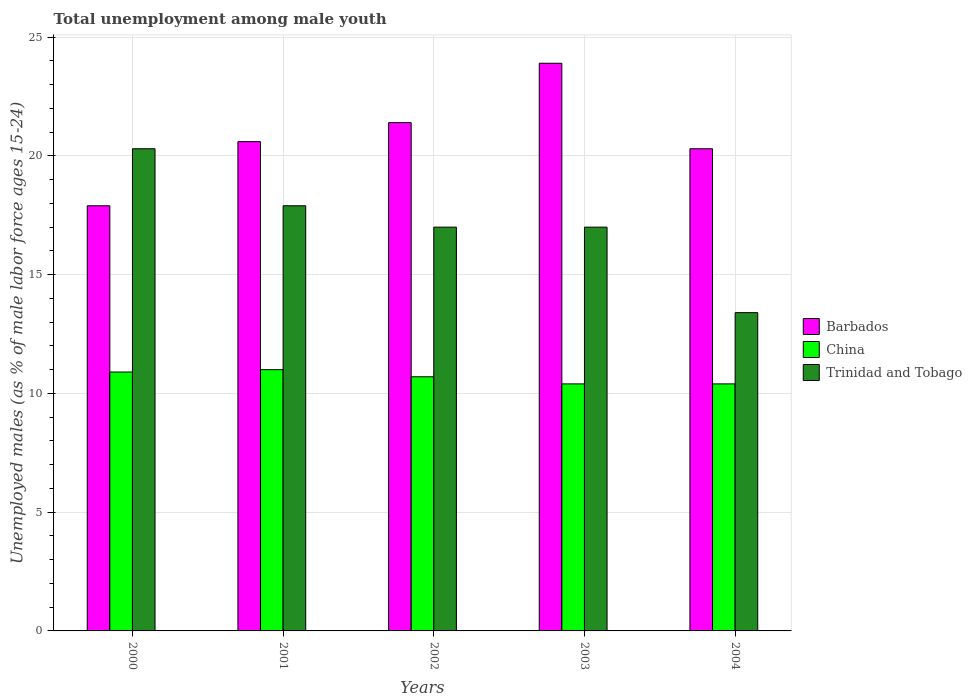How many groups of bars are there?
Give a very brief answer. 5. Are the number of bars on each tick of the X-axis equal?
Offer a terse response. Yes. How many bars are there on the 2nd tick from the right?
Provide a succinct answer. 3. What is the label of the 3rd group of bars from the left?
Offer a very short reply. 2002. What is the percentage of unemployed males in in China in 2002?
Keep it short and to the point. 10.7. Across all years, what is the maximum percentage of unemployed males in in Barbados?
Provide a short and direct response. 23.9. Across all years, what is the minimum percentage of unemployed males in in China?
Your response must be concise. 10.4. What is the total percentage of unemployed males in in China in the graph?
Ensure brevity in your answer.  53.4. What is the difference between the percentage of unemployed males in in Trinidad and Tobago in 2001 and that in 2004?
Offer a very short reply. 4.5. What is the average percentage of unemployed males in in Barbados per year?
Provide a succinct answer. 20.82. In the year 2002, what is the difference between the percentage of unemployed males in in Barbados and percentage of unemployed males in in Trinidad and Tobago?
Ensure brevity in your answer.  4.4. In how many years, is the percentage of unemployed males in in Trinidad and Tobago greater than 15 %?
Offer a terse response. 4. What is the ratio of the percentage of unemployed males in in Trinidad and Tobago in 2001 to that in 2002?
Your answer should be compact. 1.05. Is the percentage of unemployed males in in Barbados in 2000 less than that in 2001?
Offer a terse response. Yes. Is the difference between the percentage of unemployed males in in Barbados in 2001 and 2002 greater than the difference between the percentage of unemployed males in in Trinidad and Tobago in 2001 and 2002?
Offer a terse response. No. What is the difference between the highest and the second highest percentage of unemployed males in in China?
Provide a short and direct response. 0.1. What is the difference between the highest and the lowest percentage of unemployed males in in Barbados?
Make the answer very short. 6. In how many years, is the percentage of unemployed males in in Barbados greater than the average percentage of unemployed males in in Barbados taken over all years?
Provide a succinct answer. 2. Is the sum of the percentage of unemployed males in in Barbados in 2003 and 2004 greater than the maximum percentage of unemployed males in in Trinidad and Tobago across all years?
Provide a short and direct response. Yes. What does the 1st bar from the left in 2000 represents?
Ensure brevity in your answer.  Barbados. What does the 1st bar from the right in 2004 represents?
Keep it short and to the point. Trinidad and Tobago. Is it the case that in every year, the sum of the percentage of unemployed males in in Trinidad and Tobago and percentage of unemployed males in in Barbados is greater than the percentage of unemployed males in in China?
Keep it short and to the point. Yes. Are all the bars in the graph horizontal?
Provide a succinct answer. No. How many years are there in the graph?
Offer a very short reply. 5. Are the values on the major ticks of Y-axis written in scientific E-notation?
Offer a very short reply. No. Does the graph contain any zero values?
Make the answer very short. No. Does the graph contain grids?
Your response must be concise. Yes. Where does the legend appear in the graph?
Offer a very short reply. Center right. How are the legend labels stacked?
Provide a succinct answer. Vertical. What is the title of the graph?
Your answer should be compact. Total unemployment among male youth. What is the label or title of the Y-axis?
Make the answer very short. Unemployed males (as % of male labor force ages 15-24). What is the Unemployed males (as % of male labor force ages 15-24) of Barbados in 2000?
Keep it short and to the point. 17.9. What is the Unemployed males (as % of male labor force ages 15-24) of China in 2000?
Offer a very short reply. 10.9. What is the Unemployed males (as % of male labor force ages 15-24) in Trinidad and Tobago in 2000?
Your response must be concise. 20.3. What is the Unemployed males (as % of male labor force ages 15-24) of Barbados in 2001?
Provide a short and direct response. 20.6. What is the Unemployed males (as % of male labor force ages 15-24) in China in 2001?
Keep it short and to the point. 11. What is the Unemployed males (as % of male labor force ages 15-24) in Trinidad and Tobago in 2001?
Your answer should be very brief. 17.9. What is the Unemployed males (as % of male labor force ages 15-24) in Barbados in 2002?
Provide a succinct answer. 21.4. What is the Unemployed males (as % of male labor force ages 15-24) of China in 2002?
Keep it short and to the point. 10.7. What is the Unemployed males (as % of male labor force ages 15-24) of Trinidad and Tobago in 2002?
Offer a very short reply. 17. What is the Unemployed males (as % of male labor force ages 15-24) in Barbados in 2003?
Offer a terse response. 23.9. What is the Unemployed males (as % of male labor force ages 15-24) of China in 2003?
Provide a short and direct response. 10.4. What is the Unemployed males (as % of male labor force ages 15-24) in Barbados in 2004?
Your answer should be compact. 20.3. What is the Unemployed males (as % of male labor force ages 15-24) of China in 2004?
Ensure brevity in your answer.  10.4. What is the Unemployed males (as % of male labor force ages 15-24) of Trinidad and Tobago in 2004?
Ensure brevity in your answer.  13.4. Across all years, what is the maximum Unemployed males (as % of male labor force ages 15-24) of Barbados?
Offer a very short reply. 23.9. Across all years, what is the maximum Unemployed males (as % of male labor force ages 15-24) in China?
Make the answer very short. 11. Across all years, what is the maximum Unemployed males (as % of male labor force ages 15-24) of Trinidad and Tobago?
Your response must be concise. 20.3. Across all years, what is the minimum Unemployed males (as % of male labor force ages 15-24) in Barbados?
Offer a very short reply. 17.9. Across all years, what is the minimum Unemployed males (as % of male labor force ages 15-24) of China?
Your answer should be compact. 10.4. Across all years, what is the minimum Unemployed males (as % of male labor force ages 15-24) of Trinidad and Tobago?
Offer a very short reply. 13.4. What is the total Unemployed males (as % of male labor force ages 15-24) of Barbados in the graph?
Your answer should be compact. 104.1. What is the total Unemployed males (as % of male labor force ages 15-24) of China in the graph?
Offer a very short reply. 53.4. What is the total Unemployed males (as % of male labor force ages 15-24) of Trinidad and Tobago in the graph?
Offer a very short reply. 85.6. What is the difference between the Unemployed males (as % of male labor force ages 15-24) in China in 2000 and that in 2001?
Offer a terse response. -0.1. What is the difference between the Unemployed males (as % of male labor force ages 15-24) in Barbados in 2000 and that in 2002?
Your response must be concise. -3.5. What is the difference between the Unemployed males (as % of male labor force ages 15-24) of Trinidad and Tobago in 2000 and that in 2002?
Your response must be concise. 3.3. What is the difference between the Unemployed males (as % of male labor force ages 15-24) in Barbados in 2000 and that in 2003?
Give a very brief answer. -6. What is the difference between the Unemployed males (as % of male labor force ages 15-24) of China in 2000 and that in 2003?
Provide a succinct answer. 0.5. What is the difference between the Unemployed males (as % of male labor force ages 15-24) in Barbados in 2000 and that in 2004?
Your answer should be compact. -2.4. What is the difference between the Unemployed males (as % of male labor force ages 15-24) in Barbados in 2001 and that in 2002?
Offer a very short reply. -0.8. What is the difference between the Unemployed males (as % of male labor force ages 15-24) of Barbados in 2001 and that in 2003?
Your answer should be very brief. -3.3. What is the difference between the Unemployed males (as % of male labor force ages 15-24) of Trinidad and Tobago in 2001 and that in 2003?
Offer a very short reply. 0.9. What is the difference between the Unemployed males (as % of male labor force ages 15-24) in Barbados in 2002 and that in 2003?
Your response must be concise. -2.5. What is the difference between the Unemployed males (as % of male labor force ages 15-24) in China in 2002 and that in 2003?
Ensure brevity in your answer.  0.3. What is the difference between the Unemployed males (as % of male labor force ages 15-24) in Trinidad and Tobago in 2002 and that in 2003?
Ensure brevity in your answer.  0. What is the difference between the Unemployed males (as % of male labor force ages 15-24) in China in 2003 and that in 2004?
Offer a terse response. 0. What is the difference between the Unemployed males (as % of male labor force ages 15-24) of Trinidad and Tobago in 2003 and that in 2004?
Provide a short and direct response. 3.6. What is the difference between the Unemployed males (as % of male labor force ages 15-24) in Barbados in 2000 and the Unemployed males (as % of male labor force ages 15-24) in Trinidad and Tobago in 2001?
Your answer should be compact. 0. What is the difference between the Unemployed males (as % of male labor force ages 15-24) in China in 2000 and the Unemployed males (as % of male labor force ages 15-24) in Trinidad and Tobago in 2002?
Give a very brief answer. -6.1. What is the difference between the Unemployed males (as % of male labor force ages 15-24) of Barbados in 2000 and the Unemployed males (as % of male labor force ages 15-24) of Trinidad and Tobago in 2003?
Ensure brevity in your answer.  0.9. What is the difference between the Unemployed males (as % of male labor force ages 15-24) of Barbados in 2000 and the Unemployed males (as % of male labor force ages 15-24) of Trinidad and Tobago in 2004?
Offer a very short reply. 4.5. What is the difference between the Unemployed males (as % of male labor force ages 15-24) of China in 2001 and the Unemployed males (as % of male labor force ages 15-24) of Trinidad and Tobago in 2002?
Keep it short and to the point. -6. What is the difference between the Unemployed males (as % of male labor force ages 15-24) in Barbados in 2001 and the Unemployed males (as % of male labor force ages 15-24) in China in 2003?
Your response must be concise. 10.2. What is the difference between the Unemployed males (as % of male labor force ages 15-24) of Barbados in 2002 and the Unemployed males (as % of male labor force ages 15-24) of China in 2003?
Offer a terse response. 11. What is the difference between the Unemployed males (as % of male labor force ages 15-24) in Barbados in 2002 and the Unemployed males (as % of male labor force ages 15-24) in Trinidad and Tobago in 2003?
Your answer should be compact. 4.4. What is the difference between the Unemployed males (as % of male labor force ages 15-24) in China in 2002 and the Unemployed males (as % of male labor force ages 15-24) in Trinidad and Tobago in 2003?
Provide a succinct answer. -6.3. What is the difference between the Unemployed males (as % of male labor force ages 15-24) of Barbados in 2002 and the Unemployed males (as % of male labor force ages 15-24) of Trinidad and Tobago in 2004?
Make the answer very short. 8. What is the difference between the Unemployed males (as % of male labor force ages 15-24) of China in 2002 and the Unemployed males (as % of male labor force ages 15-24) of Trinidad and Tobago in 2004?
Provide a succinct answer. -2.7. What is the difference between the Unemployed males (as % of male labor force ages 15-24) in Barbados in 2003 and the Unemployed males (as % of male labor force ages 15-24) in Trinidad and Tobago in 2004?
Give a very brief answer. 10.5. What is the difference between the Unemployed males (as % of male labor force ages 15-24) in China in 2003 and the Unemployed males (as % of male labor force ages 15-24) in Trinidad and Tobago in 2004?
Provide a short and direct response. -3. What is the average Unemployed males (as % of male labor force ages 15-24) in Barbados per year?
Your answer should be very brief. 20.82. What is the average Unemployed males (as % of male labor force ages 15-24) in China per year?
Make the answer very short. 10.68. What is the average Unemployed males (as % of male labor force ages 15-24) in Trinidad and Tobago per year?
Your answer should be very brief. 17.12. In the year 2001, what is the difference between the Unemployed males (as % of male labor force ages 15-24) of Barbados and Unemployed males (as % of male labor force ages 15-24) of Trinidad and Tobago?
Keep it short and to the point. 2.7. In the year 2002, what is the difference between the Unemployed males (as % of male labor force ages 15-24) in Barbados and Unemployed males (as % of male labor force ages 15-24) in Trinidad and Tobago?
Your answer should be very brief. 4.4. In the year 2003, what is the difference between the Unemployed males (as % of male labor force ages 15-24) in Barbados and Unemployed males (as % of male labor force ages 15-24) in China?
Provide a succinct answer. 13.5. In the year 2004, what is the difference between the Unemployed males (as % of male labor force ages 15-24) of China and Unemployed males (as % of male labor force ages 15-24) of Trinidad and Tobago?
Your answer should be compact. -3. What is the ratio of the Unemployed males (as % of male labor force ages 15-24) in Barbados in 2000 to that in 2001?
Ensure brevity in your answer.  0.87. What is the ratio of the Unemployed males (as % of male labor force ages 15-24) in China in 2000 to that in 2001?
Offer a terse response. 0.99. What is the ratio of the Unemployed males (as % of male labor force ages 15-24) of Trinidad and Tobago in 2000 to that in 2001?
Ensure brevity in your answer.  1.13. What is the ratio of the Unemployed males (as % of male labor force ages 15-24) of Barbados in 2000 to that in 2002?
Ensure brevity in your answer.  0.84. What is the ratio of the Unemployed males (as % of male labor force ages 15-24) in China in 2000 to that in 2002?
Provide a short and direct response. 1.02. What is the ratio of the Unemployed males (as % of male labor force ages 15-24) in Trinidad and Tobago in 2000 to that in 2002?
Give a very brief answer. 1.19. What is the ratio of the Unemployed males (as % of male labor force ages 15-24) in Barbados in 2000 to that in 2003?
Provide a short and direct response. 0.75. What is the ratio of the Unemployed males (as % of male labor force ages 15-24) of China in 2000 to that in 2003?
Keep it short and to the point. 1.05. What is the ratio of the Unemployed males (as % of male labor force ages 15-24) in Trinidad and Tobago in 2000 to that in 2003?
Ensure brevity in your answer.  1.19. What is the ratio of the Unemployed males (as % of male labor force ages 15-24) in Barbados in 2000 to that in 2004?
Keep it short and to the point. 0.88. What is the ratio of the Unemployed males (as % of male labor force ages 15-24) in China in 2000 to that in 2004?
Provide a succinct answer. 1.05. What is the ratio of the Unemployed males (as % of male labor force ages 15-24) of Trinidad and Tobago in 2000 to that in 2004?
Ensure brevity in your answer.  1.51. What is the ratio of the Unemployed males (as % of male labor force ages 15-24) of Barbados in 2001 to that in 2002?
Your answer should be compact. 0.96. What is the ratio of the Unemployed males (as % of male labor force ages 15-24) of China in 2001 to that in 2002?
Give a very brief answer. 1.03. What is the ratio of the Unemployed males (as % of male labor force ages 15-24) of Trinidad and Tobago in 2001 to that in 2002?
Offer a terse response. 1.05. What is the ratio of the Unemployed males (as % of male labor force ages 15-24) in Barbados in 2001 to that in 2003?
Give a very brief answer. 0.86. What is the ratio of the Unemployed males (as % of male labor force ages 15-24) of China in 2001 to that in 2003?
Your answer should be compact. 1.06. What is the ratio of the Unemployed males (as % of male labor force ages 15-24) in Trinidad and Tobago in 2001 to that in 2003?
Give a very brief answer. 1.05. What is the ratio of the Unemployed males (as % of male labor force ages 15-24) of Barbados in 2001 to that in 2004?
Your response must be concise. 1.01. What is the ratio of the Unemployed males (as % of male labor force ages 15-24) in China in 2001 to that in 2004?
Offer a terse response. 1.06. What is the ratio of the Unemployed males (as % of male labor force ages 15-24) in Trinidad and Tobago in 2001 to that in 2004?
Provide a short and direct response. 1.34. What is the ratio of the Unemployed males (as % of male labor force ages 15-24) in Barbados in 2002 to that in 2003?
Ensure brevity in your answer.  0.9. What is the ratio of the Unemployed males (as % of male labor force ages 15-24) in China in 2002 to that in 2003?
Ensure brevity in your answer.  1.03. What is the ratio of the Unemployed males (as % of male labor force ages 15-24) of Barbados in 2002 to that in 2004?
Ensure brevity in your answer.  1.05. What is the ratio of the Unemployed males (as % of male labor force ages 15-24) in China in 2002 to that in 2004?
Make the answer very short. 1.03. What is the ratio of the Unemployed males (as % of male labor force ages 15-24) in Trinidad and Tobago in 2002 to that in 2004?
Keep it short and to the point. 1.27. What is the ratio of the Unemployed males (as % of male labor force ages 15-24) of Barbados in 2003 to that in 2004?
Your answer should be compact. 1.18. What is the ratio of the Unemployed males (as % of male labor force ages 15-24) of China in 2003 to that in 2004?
Your answer should be very brief. 1. What is the ratio of the Unemployed males (as % of male labor force ages 15-24) in Trinidad and Tobago in 2003 to that in 2004?
Ensure brevity in your answer.  1.27. What is the difference between the highest and the second highest Unemployed males (as % of male labor force ages 15-24) in Barbados?
Make the answer very short. 2.5. What is the difference between the highest and the second highest Unemployed males (as % of male labor force ages 15-24) in Trinidad and Tobago?
Your answer should be compact. 2.4. What is the difference between the highest and the lowest Unemployed males (as % of male labor force ages 15-24) of China?
Ensure brevity in your answer.  0.6. 